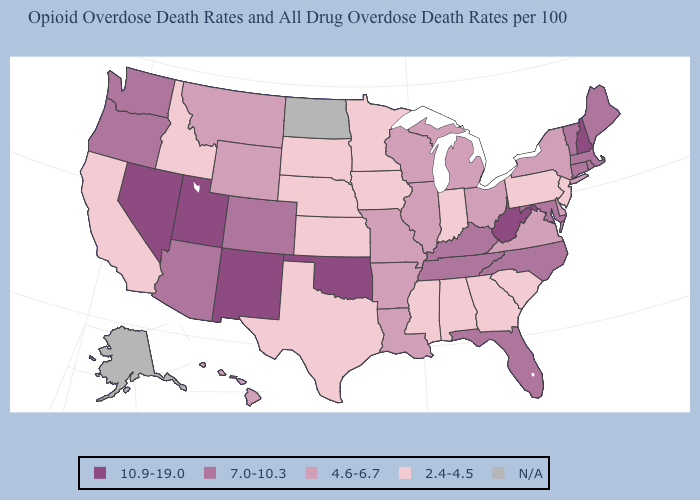Does Nebraska have the lowest value in the USA?
Keep it brief. Yes. What is the value of Ohio?
Be succinct. 4.6-6.7. What is the value of Florida?
Quick response, please. 7.0-10.3. Among the states that border Idaho , does Wyoming have the lowest value?
Answer briefly. Yes. Name the states that have a value in the range N/A?
Write a very short answer. Alaska, North Dakota. What is the lowest value in the USA?
Write a very short answer. 2.4-4.5. Does Georgia have the lowest value in the USA?
Give a very brief answer. Yes. Among the states that border North Dakota , which have the highest value?
Write a very short answer. Montana. Which states have the lowest value in the West?
Be succinct. California, Idaho. What is the lowest value in states that border Mississippi?
Write a very short answer. 2.4-4.5. Does the first symbol in the legend represent the smallest category?
Answer briefly. No. Which states have the lowest value in the USA?
Concise answer only. Alabama, California, Georgia, Idaho, Indiana, Iowa, Kansas, Minnesota, Mississippi, Nebraska, New Jersey, Pennsylvania, South Carolina, South Dakota, Texas. What is the lowest value in the USA?
Quick response, please. 2.4-4.5. Among the states that border Connecticut , does New York have the highest value?
Keep it brief. No. Does Montana have the lowest value in the West?
Write a very short answer. No. 